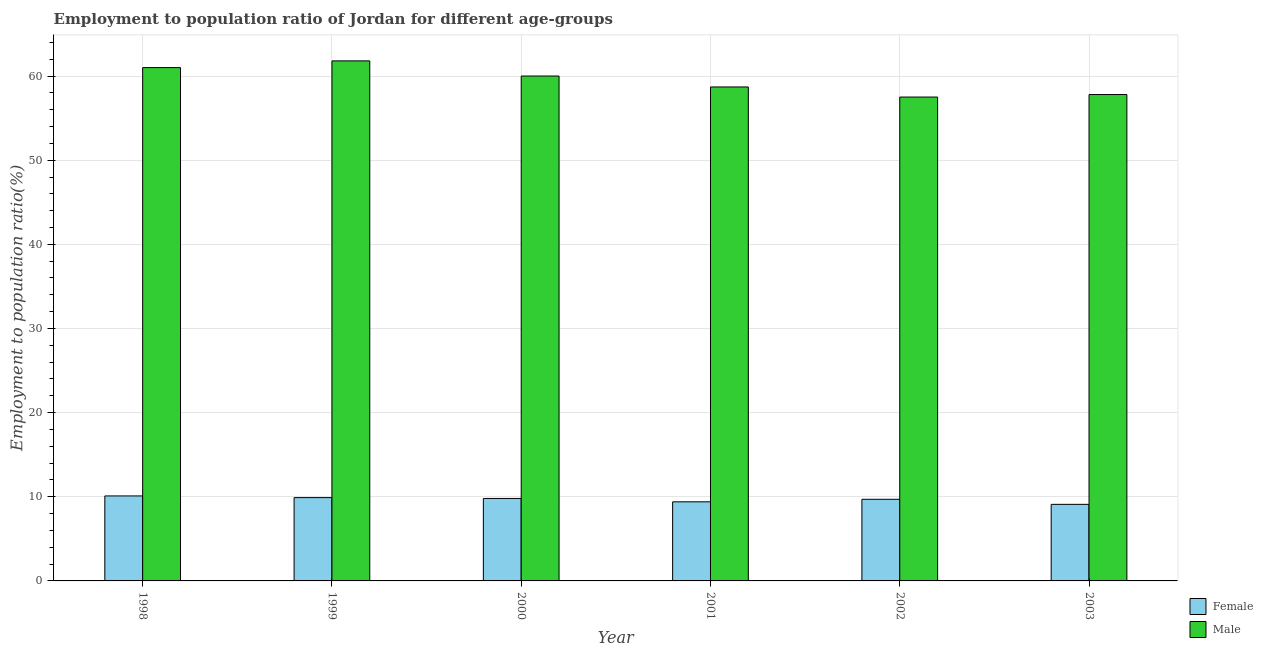How many groups of bars are there?
Provide a succinct answer. 6. Are the number of bars per tick equal to the number of legend labels?
Offer a very short reply. Yes. Are the number of bars on each tick of the X-axis equal?
Your response must be concise. Yes. How many bars are there on the 1st tick from the left?
Your answer should be very brief. 2. What is the label of the 3rd group of bars from the left?
Offer a terse response. 2000. What is the employment to population ratio(male) in 2003?
Offer a very short reply. 57.8. Across all years, what is the maximum employment to population ratio(male)?
Make the answer very short. 61.8. Across all years, what is the minimum employment to population ratio(male)?
Keep it short and to the point. 57.5. In which year was the employment to population ratio(male) maximum?
Provide a short and direct response. 1999. In which year was the employment to population ratio(female) minimum?
Give a very brief answer. 2003. What is the total employment to population ratio(female) in the graph?
Your response must be concise. 58. What is the difference between the employment to population ratio(female) in 1998 and that in 2000?
Ensure brevity in your answer.  0.3. What is the difference between the employment to population ratio(male) in 2001 and the employment to population ratio(female) in 2002?
Your answer should be very brief. 1.2. What is the average employment to population ratio(female) per year?
Ensure brevity in your answer.  9.67. In how many years, is the employment to population ratio(female) greater than 18 %?
Your answer should be compact. 0. What is the ratio of the employment to population ratio(male) in 2002 to that in 2003?
Your answer should be very brief. 0.99. Is the employment to population ratio(male) in 2000 less than that in 2002?
Provide a short and direct response. No. What is the difference between the highest and the second highest employment to population ratio(male)?
Your answer should be very brief. 0.8. What is the difference between the highest and the lowest employment to population ratio(male)?
Your answer should be compact. 4.3. In how many years, is the employment to population ratio(female) greater than the average employment to population ratio(female) taken over all years?
Your response must be concise. 4. Is the sum of the employment to population ratio(female) in 1998 and 2001 greater than the maximum employment to population ratio(male) across all years?
Give a very brief answer. Yes. What does the 2nd bar from the left in 2002 represents?
Your answer should be very brief. Male. How many bars are there?
Your answer should be very brief. 12. How many years are there in the graph?
Make the answer very short. 6. Does the graph contain any zero values?
Keep it short and to the point. No. What is the title of the graph?
Your answer should be compact. Employment to population ratio of Jordan for different age-groups. What is the label or title of the Y-axis?
Your response must be concise. Employment to population ratio(%). What is the Employment to population ratio(%) in Female in 1998?
Ensure brevity in your answer.  10.1. What is the Employment to population ratio(%) in Female in 1999?
Your response must be concise. 9.9. What is the Employment to population ratio(%) in Male in 1999?
Provide a short and direct response. 61.8. What is the Employment to population ratio(%) in Female in 2000?
Make the answer very short. 9.8. What is the Employment to population ratio(%) in Male in 2000?
Provide a succinct answer. 60. What is the Employment to population ratio(%) of Female in 2001?
Make the answer very short. 9.4. What is the Employment to population ratio(%) of Male in 2001?
Make the answer very short. 58.7. What is the Employment to population ratio(%) in Female in 2002?
Ensure brevity in your answer.  9.7. What is the Employment to population ratio(%) in Male in 2002?
Provide a succinct answer. 57.5. What is the Employment to population ratio(%) in Female in 2003?
Provide a succinct answer. 9.1. What is the Employment to population ratio(%) of Male in 2003?
Give a very brief answer. 57.8. Across all years, what is the maximum Employment to population ratio(%) of Female?
Offer a very short reply. 10.1. Across all years, what is the maximum Employment to population ratio(%) of Male?
Ensure brevity in your answer.  61.8. Across all years, what is the minimum Employment to population ratio(%) in Female?
Make the answer very short. 9.1. Across all years, what is the minimum Employment to population ratio(%) of Male?
Offer a very short reply. 57.5. What is the total Employment to population ratio(%) of Male in the graph?
Your answer should be compact. 356.8. What is the difference between the Employment to population ratio(%) of Female in 1998 and that in 2000?
Ensure brevity in your answer.  0.3. What is the difference between the Employment to population ratio(%) in Male in 1998 and that in 2001?
Offer a very short reply. 2.3. What is the difference between the Employment to population ratio(%) in Female in 1998 and that in 2002?
Your answer should be very brief. 0.4. What is the difference between the Employment to population ratio(%) in Female in 1998 and that in 2003?
Offer a terse response. 1. What is the difference between the Employment to population ratio(%) in Male in 1999 and that in 2000?
Your response must be concise. 1.8. What is the difference between the Employment to population ratio(%) in Male in 1999 and that in 2001?
Ensure brevity in your answer.  3.1. What is the difference between the Employment to population ratio(%) in Male in 1999 and that in 2002?
Offer a terse response. 4.3. What is the difference between the Employment to population ratio(%) of Male in 2000 and that in 2002?
Your response must be concise. 2.5. What is the difference between the Employment to population ratio(%) of Female in 2000 and that in 2003?
Offer a very short reply. 0.7. What is the difference between the Employment to population ratio(%) in Female in 1998 and the Employment to population ratio(%) in Male in 1999?
Provide a succinct answer. -51.7. What is the difference between the Employment to population ratio(%) in Female in 1998 and the Employment to population ratio(%) in Male in 2000?
Offer a very short reply. -49.9. What is the difference between the Employment to population ratio(%) in Female in 1998 and the Employment to population ratio(%) in Male in 2001?
Give a very brief answer. -48.6. What is the difference between the Employment to population ratio(%) in Female in 1998 and the Employment to population ratio(%) in Male in 2002?
Make the answer very short. -47.4. What is the difference between the Employment to population ratio(%) of Female in 1998 and the Employment to population ratio(%) of Male in 2003?
Provide a succinct answer. -47.7. What is the difference between the Employment to population ratio(%) in Female in 1999 and the Employment to population ratio(%) in Male in 2000?
Keep it short and to the point. -50.1. What is the difference between the Employment to population ratio(%) in Female in 1999 and the Employment to population ratio(%) in Male in 2001?
Ensure brevity in your answer.  -48.8. What is the difference between the Employment to population ratio(%) of Female in 1999 and the Employment to population ratio(%) of Male in 2002?
Offer a terse response. -47.6. What is the difference between the Employment to population ratio(%) of Female in 1999 and the Employment to population ratio(%) of Male in 2003?
Your answer should be very brief. -47.9. What is the difference between the Employment to population ratio(%) of Female in 2000 and the Employment to population ratio(%) of Male in 2001?
Provide a short and direct response. -48.9. What is the difference between the Employment to population ratio(%) of Female in 2000 and the Employment to population ratio(%) of Male in 2002?
Offer a terse response. -47.7. What is the difference between the Employment to population ratio(%) of Female in 2000 and the Employment to population ratio(%) of Male in 2003?
Offer a terse response. -48. What is the difference between the Employment to population ratio(%) in Female in 2001 and the Employment to population ratio(%) in Male in 2002?
Offer a very short reply. -48.1. What is the difference between the Employment to population ratio(%) of Female in 2001 and the Employment to population ratio(%) of Male in 2003?
Offer a terse response. -48.4. What is the difference between the Employment to population ratio(%) of Female in 2002 and the Employment to population ratio(%) of Male in 2003?
Make the answer very short. -48.1. What is the average Employment to population ratio(%) of Female per year?
Give a very brief answer. 9.67. What is the average Employment to population ratio(%) in Male per year?
Make the answer very short. 59.47. In the year 1998, what is the difference between the Employment to population ratio(%) of Female and Employment to population ratio(%) of Male?
Provide a short and direct response. -50.9. In the year 1999, what is the difference between the Employment to population ratio(%) in Female and Employment to population ratio(%) in Male?
Keep it short and to the point. -51.9. In the year 2000, what is the difference between the Employment to population ratio(%) of Female and Employment to population ratio(%) of Male?
Your response must be concise. -50.2. In the year 2001, what is the difference between the Employment to population ratio(%) of Female and Employment to population ratio(%) of Male?
Offer a terse response. -49.3. In the year 2002, what is the difference between the Employment to population ratio(%) of Female and Employment to population ratio(%) of Male?
Your response must be concise. -47.8. In the year 2003, what is the difference between the Employment to population ratio(%) of Female and Employment to population ratio(%) of Male?
Your response must be concise. -48.7. What is the ratio of the Employment to population ratio(%) of Female in 1998 to that in 1999?
Provide a short and direct response. 1.02. What is the ratio of the Employment to population ratio(%) in Male in 1998 to that in 1999?
Ensure brevity in your answer.  0.99. What is the ratio of the Employment to population ratio(%) in Female in 1998 to that in 2000?
Your answer should be compact. 1.03. What is the ratio of the Employment to population ratio(%) in Male in 1998 to that in 2000?
Your response must be concise. 1.02. What is the ratio of the Employment to population ratio(%) of Female in 1998 to that in 2001?
Offer a very short reply. 1.07. What is the ratio of the Employment to population ratio(%) of Male in 1998 to that in 2001?
Ensure brevity in your answer.  1.04. What is the ratio of the Employment to population ratio(%) in Female in 1998 to that in 2002?
Ensure brevity in your answer.  1.04. What is the ratio of the Employment to population ratio(%) in Male in 1998 to that in 2002?
Offer a very short reply. 1.06. What is the ratio of the Employment to population ratio(%) in Female in 1998 to that in 2003?
Offer a terse response. 1.11. What is the ratio of the Employment to population ratio(%) in Male in 1998 to that in 2003?
Ensure brevity in your answer.  1.06. What is the ratio of the Employment to population ratio(%) of Female in 1999 to that in 2000?
Offer a very short reply. 1.01. What is the ratio of the Employment to population ratio(%) of Female in 1999 to that in 2001?
Provide a succinct answer. 1.05. What is the ratio of the Employment to population ratio(%) of Male in 1999 to that in 2001?
Provide a succinct answer. 1.05. What is the ratio of the Employment to population ratio(%) in Female in 1999 to that in 2002?
Make the answer very short. 1.02. What is the ratio of the Employment to population ratio(%) in Male in 1999 to that in 2002?
Your answer should be compact. 1.07. What is the ratio of the Employment to population ratio(%) in Female in 1999 to that in 2003?
Provide a succinct answer. 1.09. What is the ratio of the Employment to population ratio(%) in Male in 1999 to that in 2003?
Provide a short and direct response. 1.07. What is the ratio of the Employment to population ratio(%) of Female in 2000 to that in 2001?
Your answer should be very brief. 1.04. What is the ratio of the Employment to population ratio(%) of Male in 2000 to that in 2001?
Make the answer very short. 1.02. What is the ratio of the Employment to population ratio(%) of Female in 2000 to that in 2002?
Ensure brevity in your answer.  1.01. What is the ratio of the Employment to population ratio(%) of Male in 2000 to that in 2002?
Your response must be concise. 1.04. What is the ratio of the Employment to population ratio(%) of Female in 2000 to that in 2003?
Your answer should be compact. 1.08. What is the ratio of the Employment to population ratio(%) in Male in 2000 to that in 2003?
Provide a short and direct response. 1.04. What is the ratio of the Employment to population ratio(%) in Female in 2001 to that in 2002?
Offer a terse response. 0.97. What is the ratio of the Employment to population ratio(%) in Male in 2001 to that in 2002?
Make the answer very short. 1.02. What is the ratio of the Employment to population ratio(%) of Female in 2001 to that in 2003?
Provide a short and direct response. 1.03. What is the ratio of the Employment to population ratio(%) of Male in 2001 to that in 2003?
Offer a very short reply. 1.02. What is the ratio of the Employment to population ratio(%) of Female in 2002 to that in 2003?
Keep it short and to the point. 1.07. What is the difference between the highest and the second highest Employment to population ratio(%) in Female?
Ensure brevity in your answer.  0.2. What is the difference between the highest and the lowest Employment to population ratio(%) in Male?
Keep it short and to the point. 4.3. 